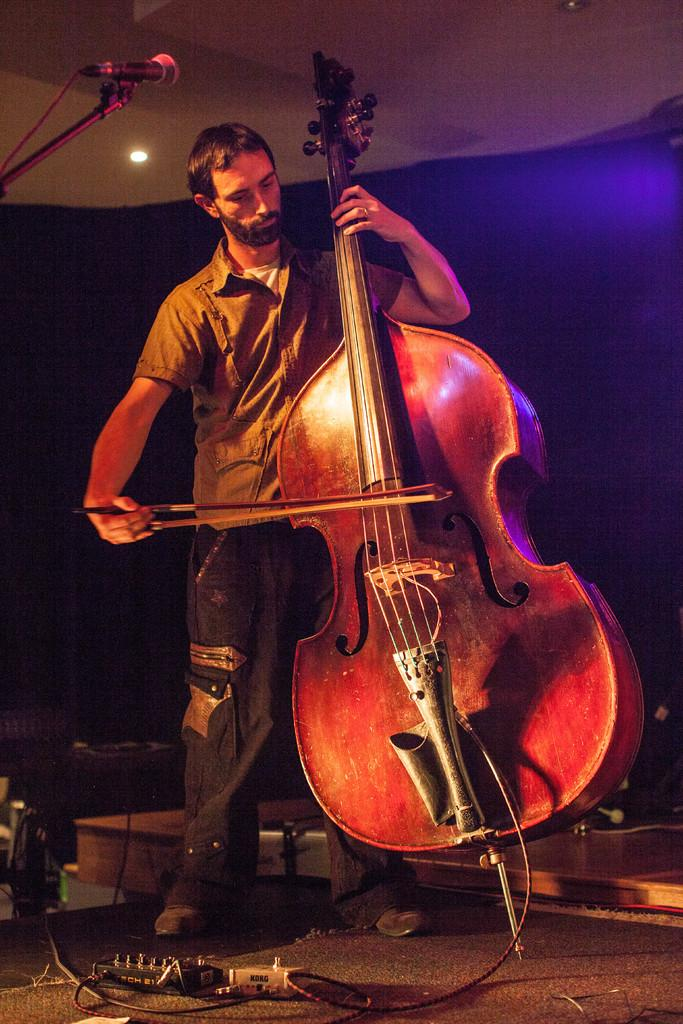Who is in the image? There is a person in the image. What is the person holding? The person is holding a violin. What is the person doing with the violin? The person is playing the violin. What can be seen in the background of the image? There are wires, a curtain, a light, and a microphone in the background of the image. Can you see a tub in the image? No, there is no tub present in the image. What type of control is being used by the person to play the violin? The person is playing the violin by holding it and using a bow, not a control. 